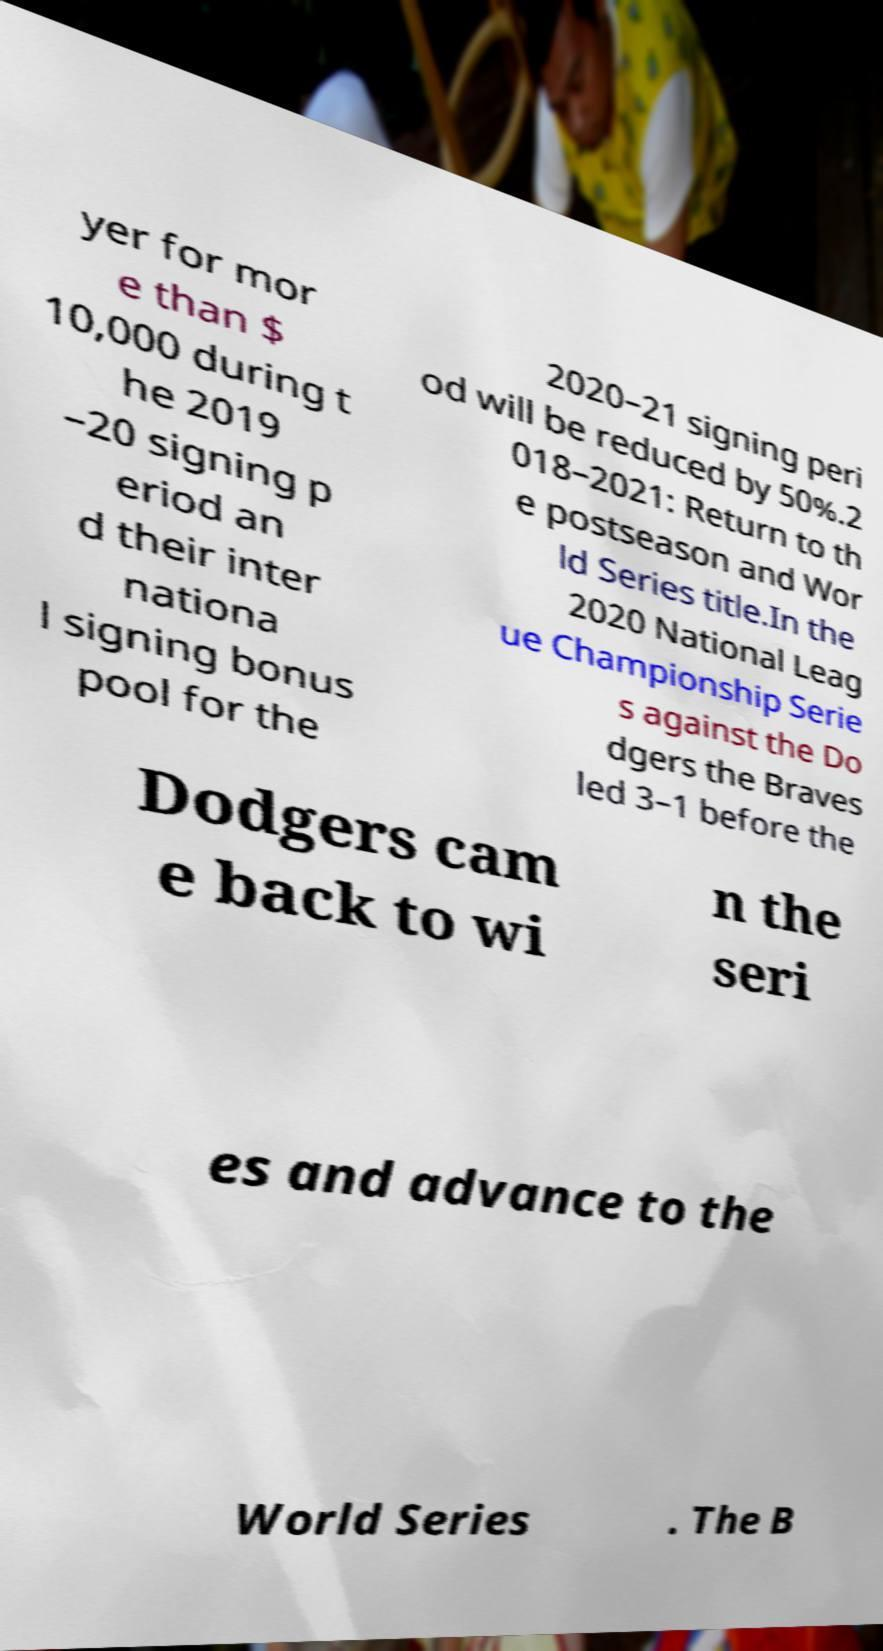Can you read and provide the text displayed in the image?This photo seems to have some interesting text. Can you extract and type it out for me? yer for mor e than $ 10,000 during t he 2019 –20 signing p eriod an d their inter nationa l signing bonus pool for the 2020–21 signing peri od will be reduced by 50%.2 018–2021: Return to th e postseason and Wor ld Series title.In the 2020 National Leag ue Championship Serie s against the Do dgers the Braves led 3–1 before the Dodgers cam e back to wi n the seri es and advance to the World Series . The B 